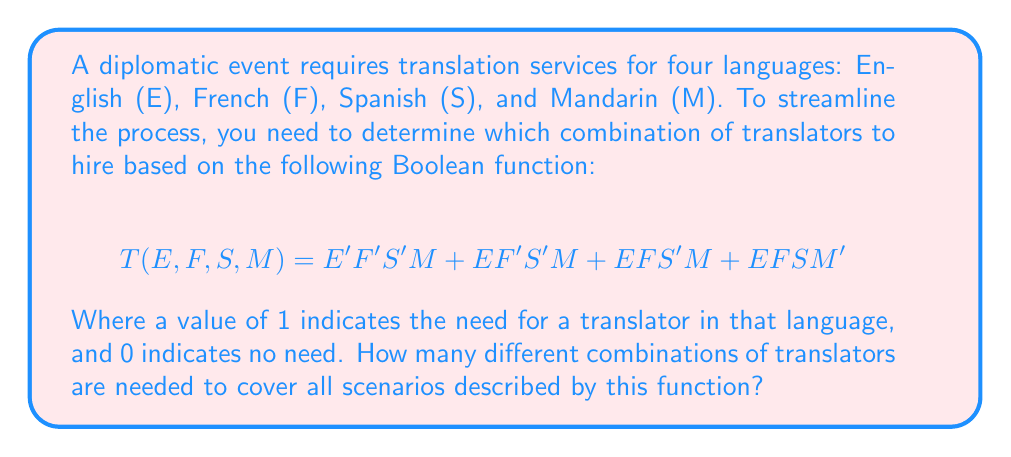What is the answer to this math problem? Let's approach this step-by-step:

1) First, we need to understand what each term in the Boolean function represents:
   - $E'F'S'M$: Only Mandarin is needed
   - $EF'S'M$: English and Mandarin are needed
   - $EFS'M$: English, French, and Mandarin are needed
   - $EFSM'$: English, French, and Spanish are needed

2) Now, let's count the unique combinations:
   a) $E'F'S'M$: (0,0,0,1)
   b) $EF'S'M$: (1,0,0,1)
   c) $EFS'M$: (1,1,0,1)
   d) $EFSM'$: (1,1,1,0)

3) Each of these represents a different combination of translators needed.

4) Therefore, we have 4 unique combinations of translators needed to cover all scenarios described by this function.

This Boolean function effectively streamlines the hiring process by identifying the exact combinations of language skills required for different scenarios, ensuring efficient allocation of translation resources for the diplomatic event.
Answer: 4 